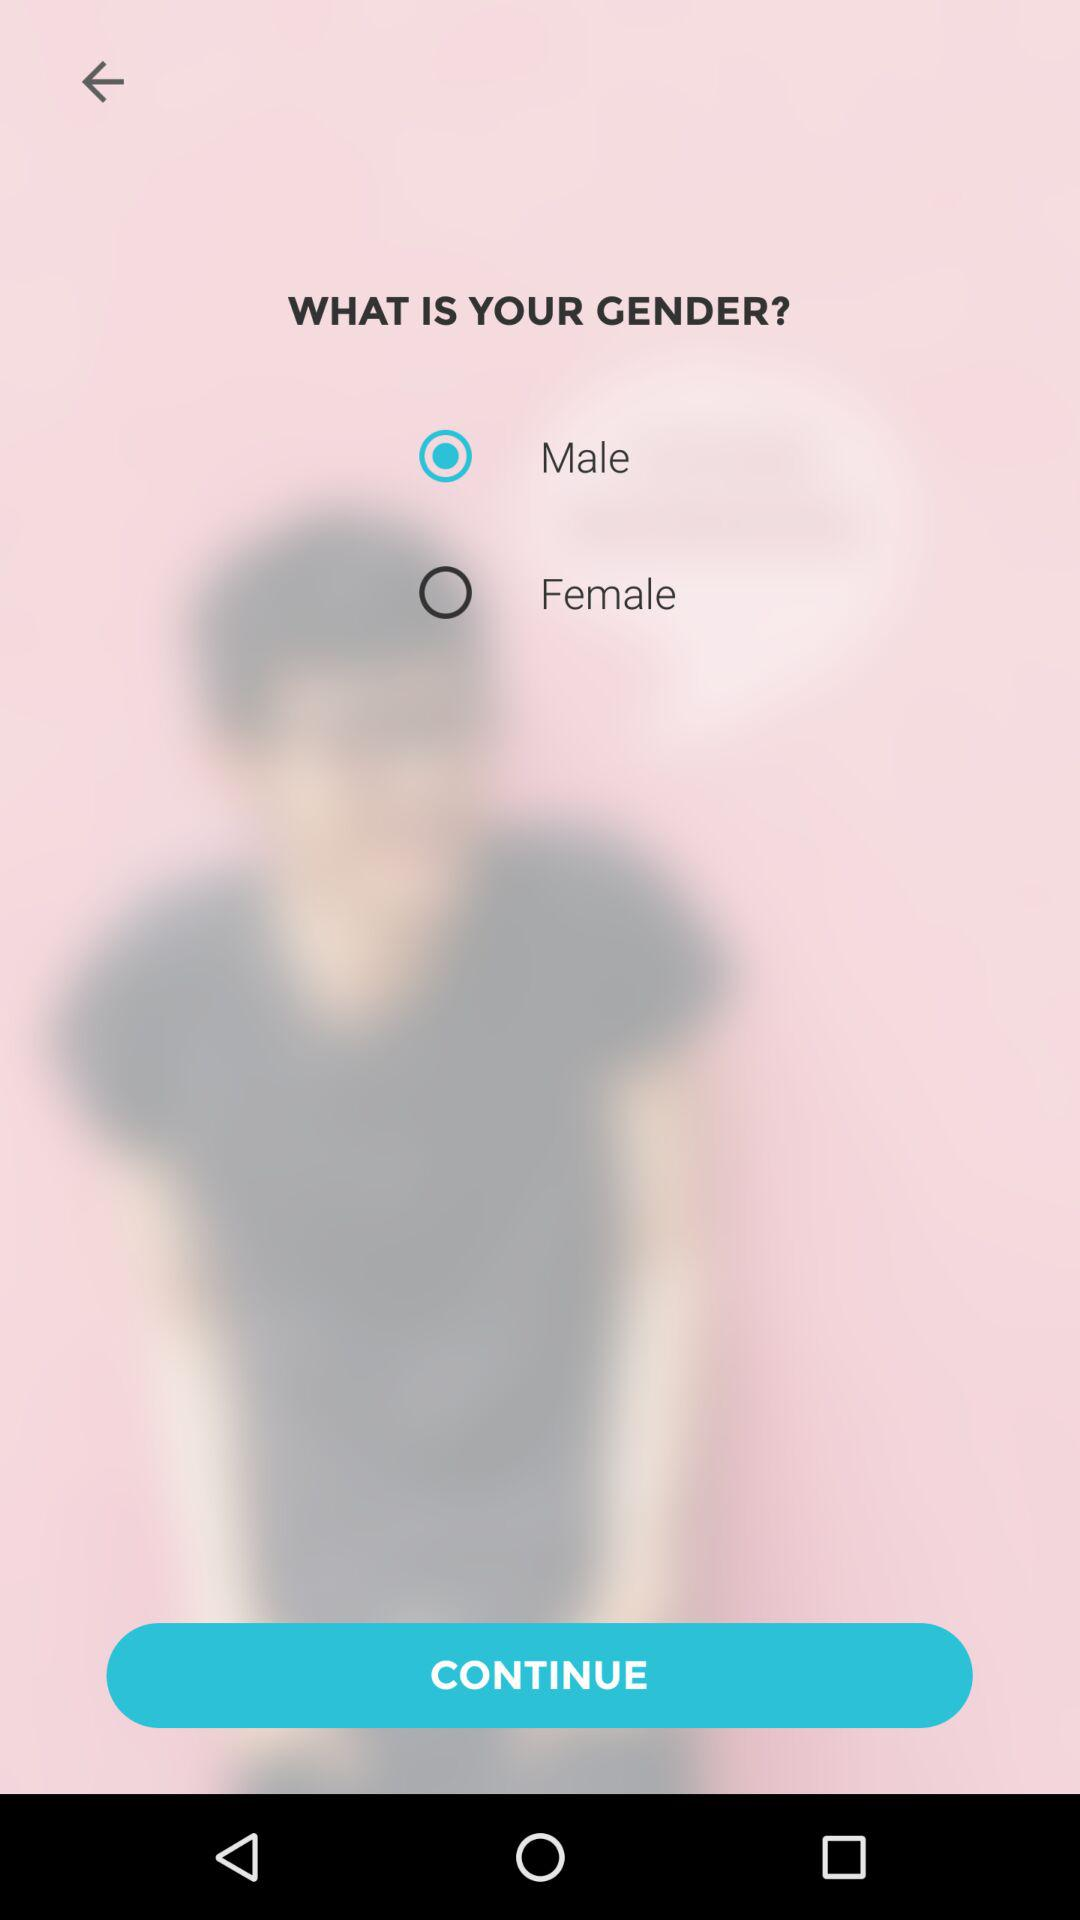What is the user's name?
When the provided information is insufficient, respond with <no answer>. <no answer> 